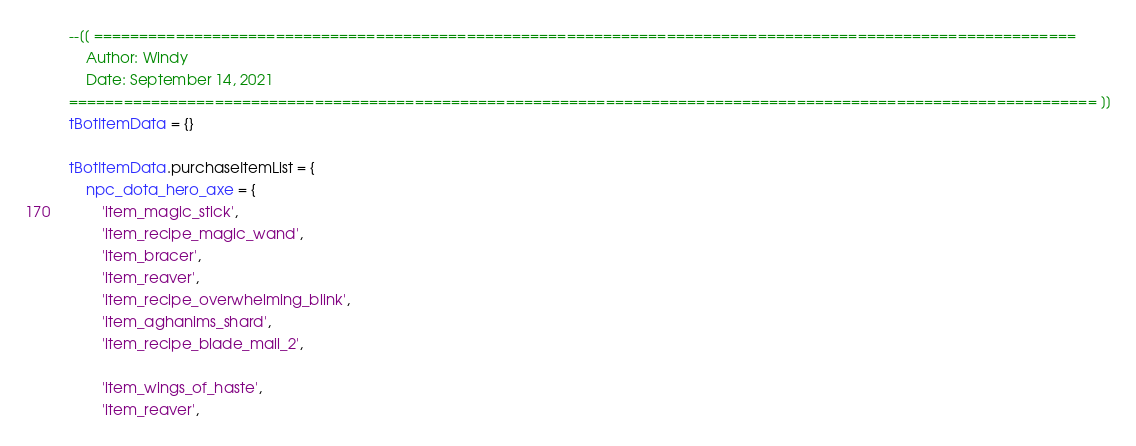Convert code to text. <code><loc_0><loc_0><loc_500><loc_500><_Lua_>--[[ ============================================================================================================
	Author: Windy
	Date: September 14, 2021
================================================================================================================= ]]
tBotItemData = {}

tBotItemData.purchaseItemList = {
	npc_dota_hero_axe = {
		'item_magic_stick',
		'item_recipe_magic_wand',
		'item_bracer',
		'item_reaver',
		'item_recipe_overwhelming_blink',
		'item_aghanims_shard',
		'item_recipe_blade_mail_2',
		
		'item_wings_of_haste',
		'item_reaver',</code> 